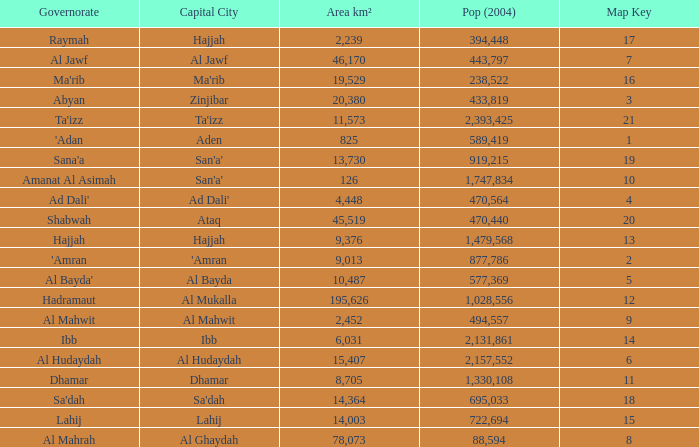How many Pop (2004) has a Governorate of al mahwit? 494557.0. 